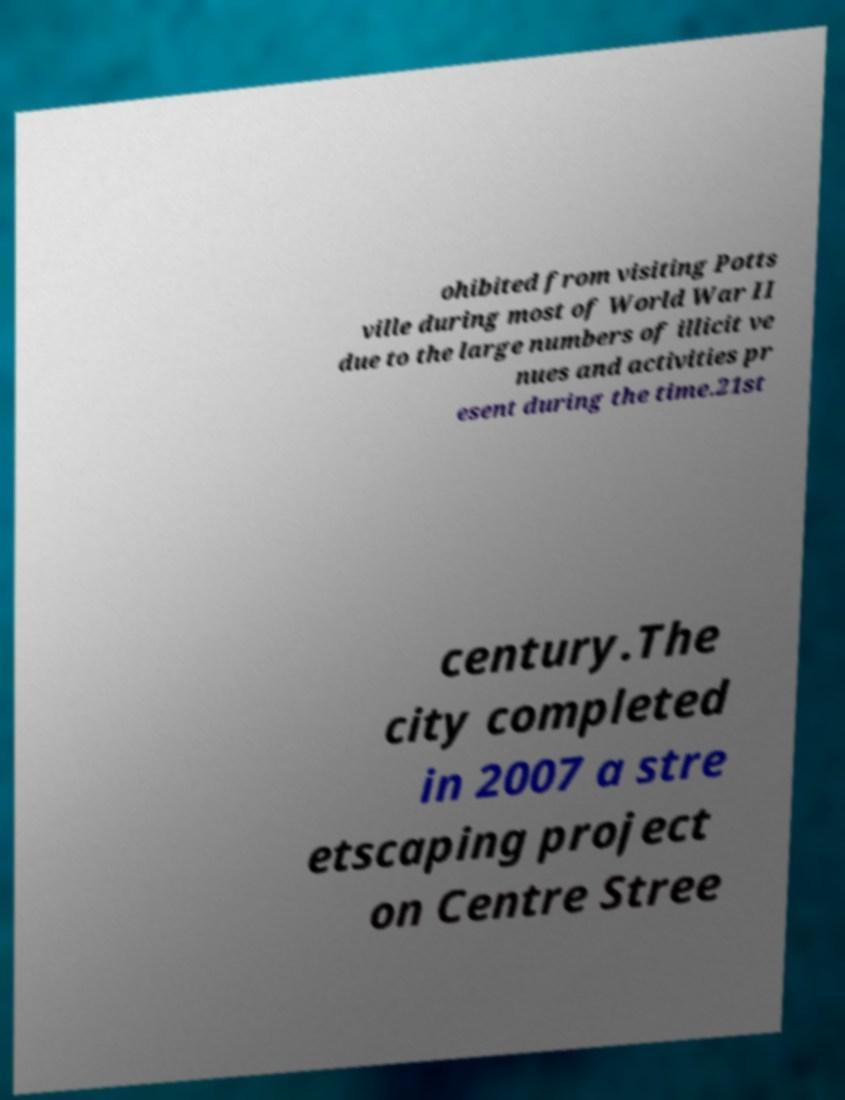Please read and relay the text visible in this image. What does it say? ohibited from visiting Potts ville during most of World War II due to the large numbers of illicit ve nues and activities pr esent during the time.21st century.The city completed in 2007 a stre etscaping project on Centre Stree 